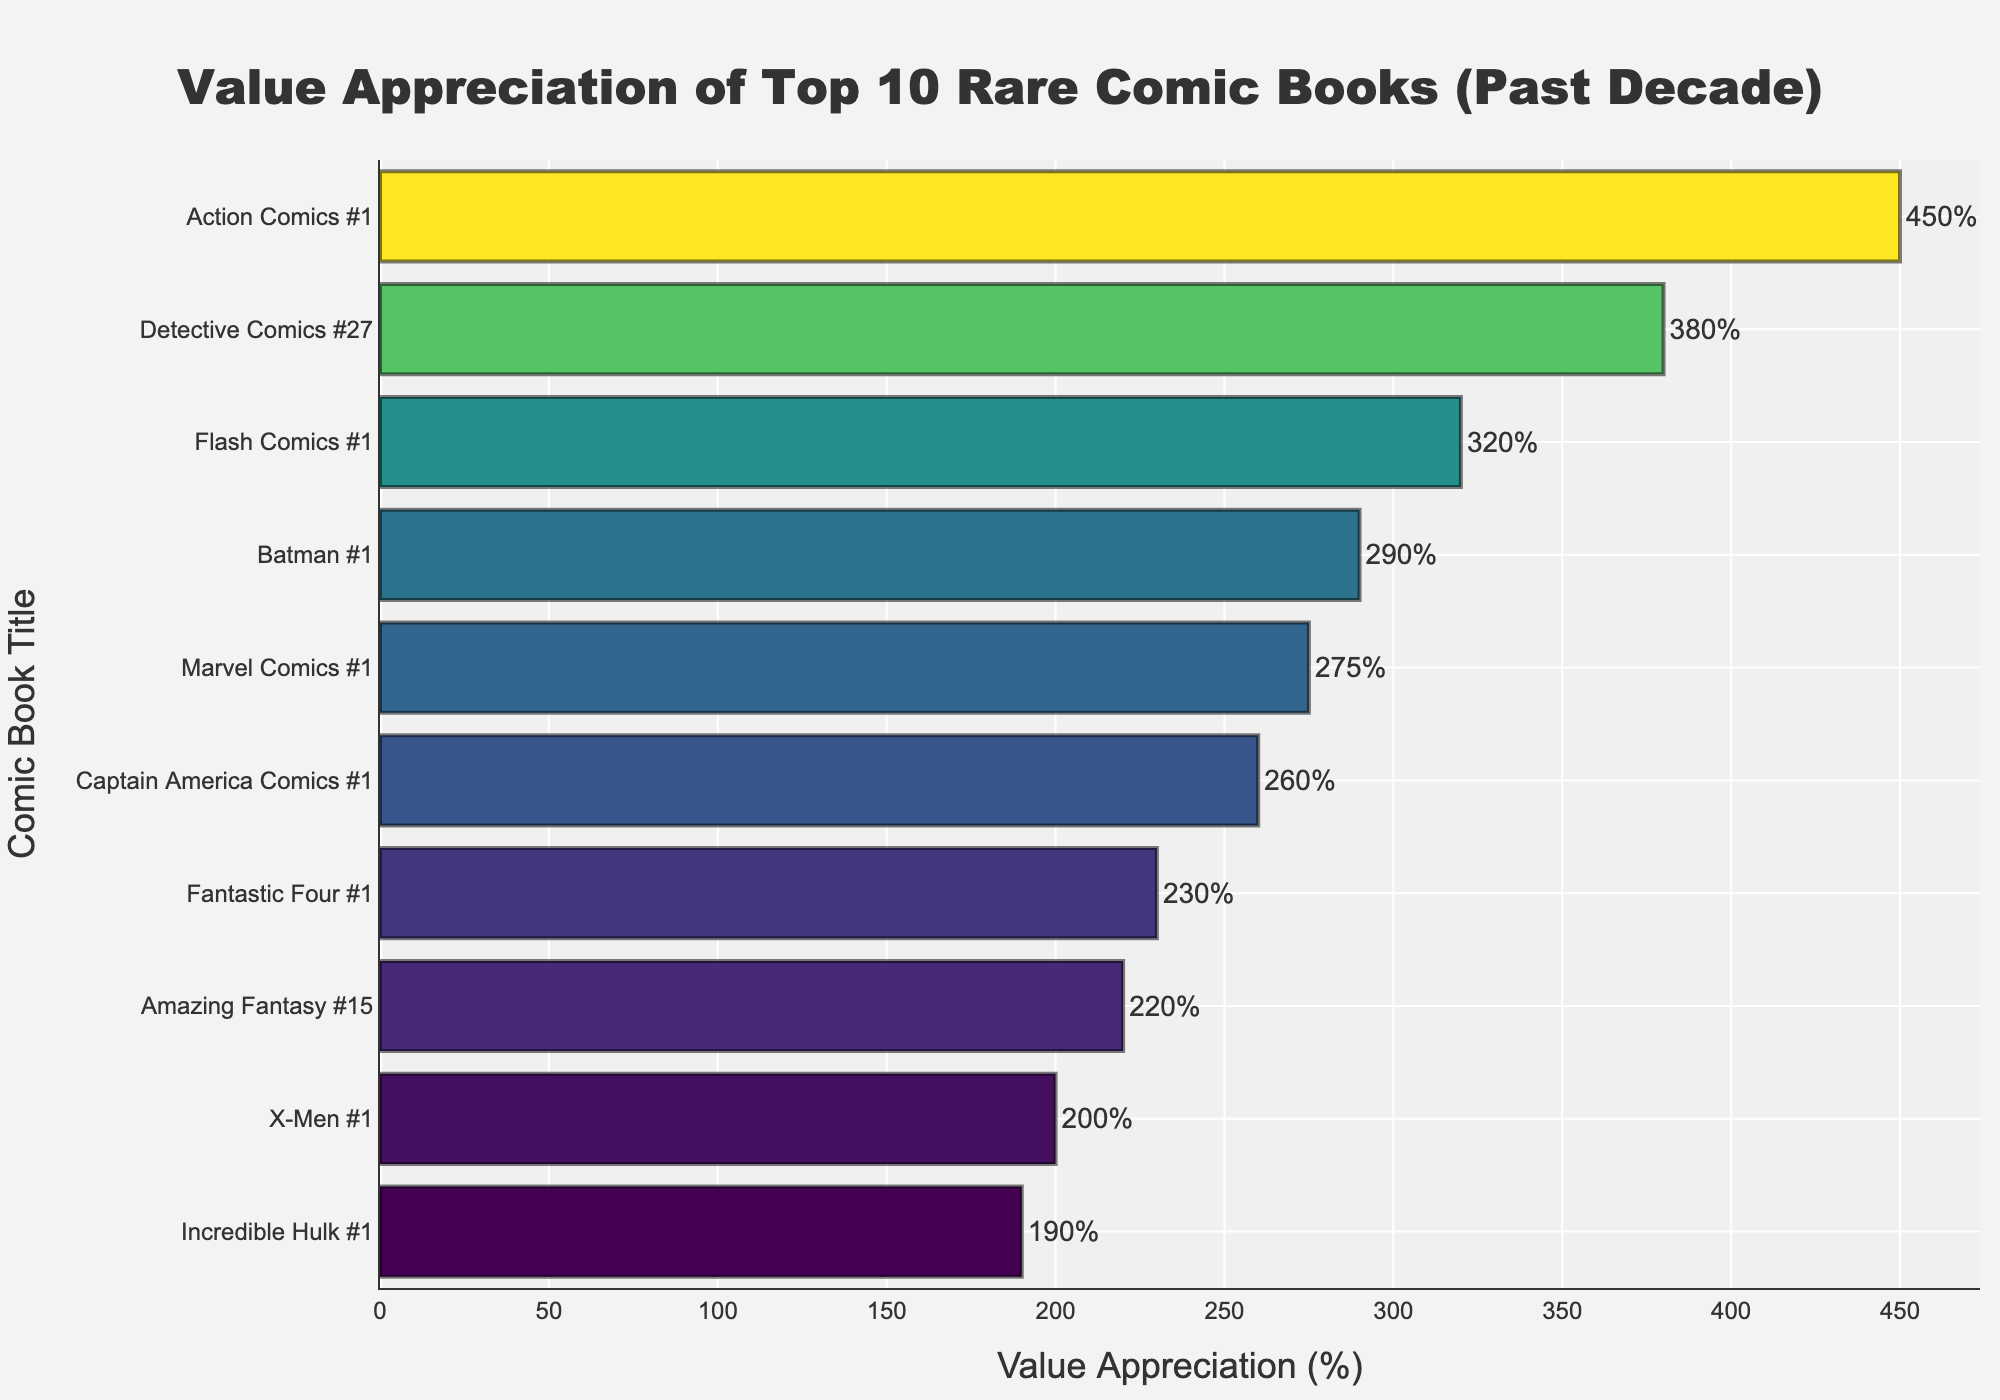Which comic book has the highest value appreciation? The highest value appreciation is at the top of the ascending bar chart, which corresponds to Action Comics #1 with 450%.
Answer: Action Comics #1 Compare the value appreciation between Action Comics #1 and Batman #1. Action Comics #1 has a value appreciation of 450%, while Batman #1 has 290%. Action Comics #1's bar is longer, indicating higher appreciation. The difference is 450% - 290% = 160%.
Answer: Action Comics #1 is higher by 160% What is the average value appreciation of the top 5 comic books? The top 5 comic books are Action Comics #1 (450%), Detective Comics #27 (380%), Flash Comics #1 (320%), Batman #1 (290%), and Marvel Comics #1 (275%). Their sum is 450 + 380 + 320 + 290 + 275 = 1715. The average is 1715 / 5 = 343%.
Answer: 343% What is the median value appreciation among the top 10 comic books? Sorting the value appreciations we have: 190%, 200%, 220%, 230%, 260%, 275%, 290%, 320%, 380%, 450%. The median is the average of the 5th and 6th values: (260 + 275) / 2 = 267.5%.
Answer: 267.5% Which comic book has the least value appreciation and what is its value appreciation percentage? The shortest bar in the chart represents the comic book with the least value appreciation, which is Incredible Hulk #1 with 190%.
Answer: Incredible Hulk #1, 190% How much more appreciation does Detective Comics #27 have compared to X-Men #1? Detective Comics #27 has 380%, and X-Men #1 has 200%. The difference is 380% - 200% = 180%.
Answer: 180% If the value appreciation percentages of the top 3 comic books were summed, what would the total be? The top 3 comics are Action Comics #1 (450%), Detective Comics #27 (380%), and Flash Comics #1 (320%). The sum is 450 + 380 + 320 = 1150%.
Answer: 1150% Which comic book has a value appreciation closest to 300% and what is its exact percentage? Batman #1 has a value appreciation of 290%, which is closest to 300% as seen from the chart.
Answer: Batman #1, 290% What is the combined value appreciation of Amazing Fantasy #15 and Fantastic Four #1? Amazing Fantasy #15 has 220% and Fantastic Four #1 has 230%. The combined value appreciation is 220% + 230% = 450%.
Answer: 450% Is the value appreciation of Captain America Comics #1 greater than the average value appreciation of X-Men #1 and Incredible Hulk #1? Average value appreciation of X-Men #1 (200%) and Incredible Hulk #1 (190%) is (200% + 190%) / 2 = 195%. Captain America Comics #1 has 260%, which is greater than 195%.
Answer: Yes, Captain America Comics #1 is greater 